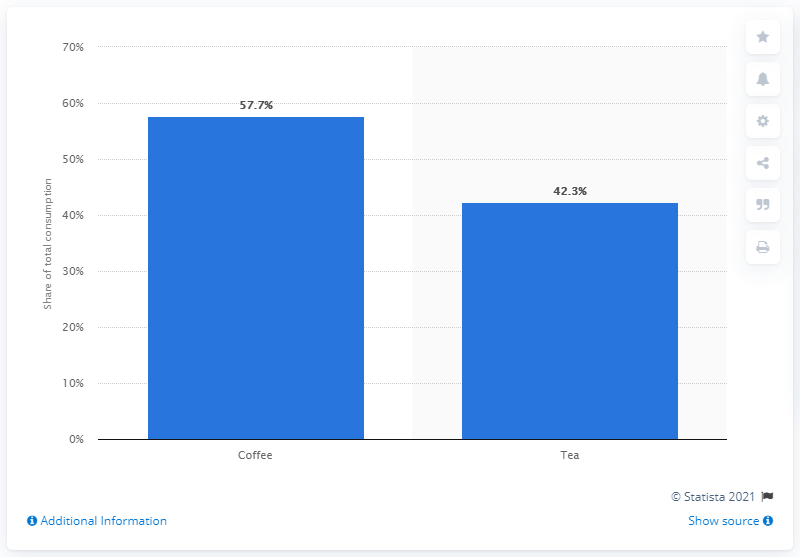Draw attention to some important aspects in this diagram. In 2012, the percentage of tea consumption in Canada was 42.3%. In 2012, coffee accounted for 57.7% of total coffee and tea consumption in Canada. 